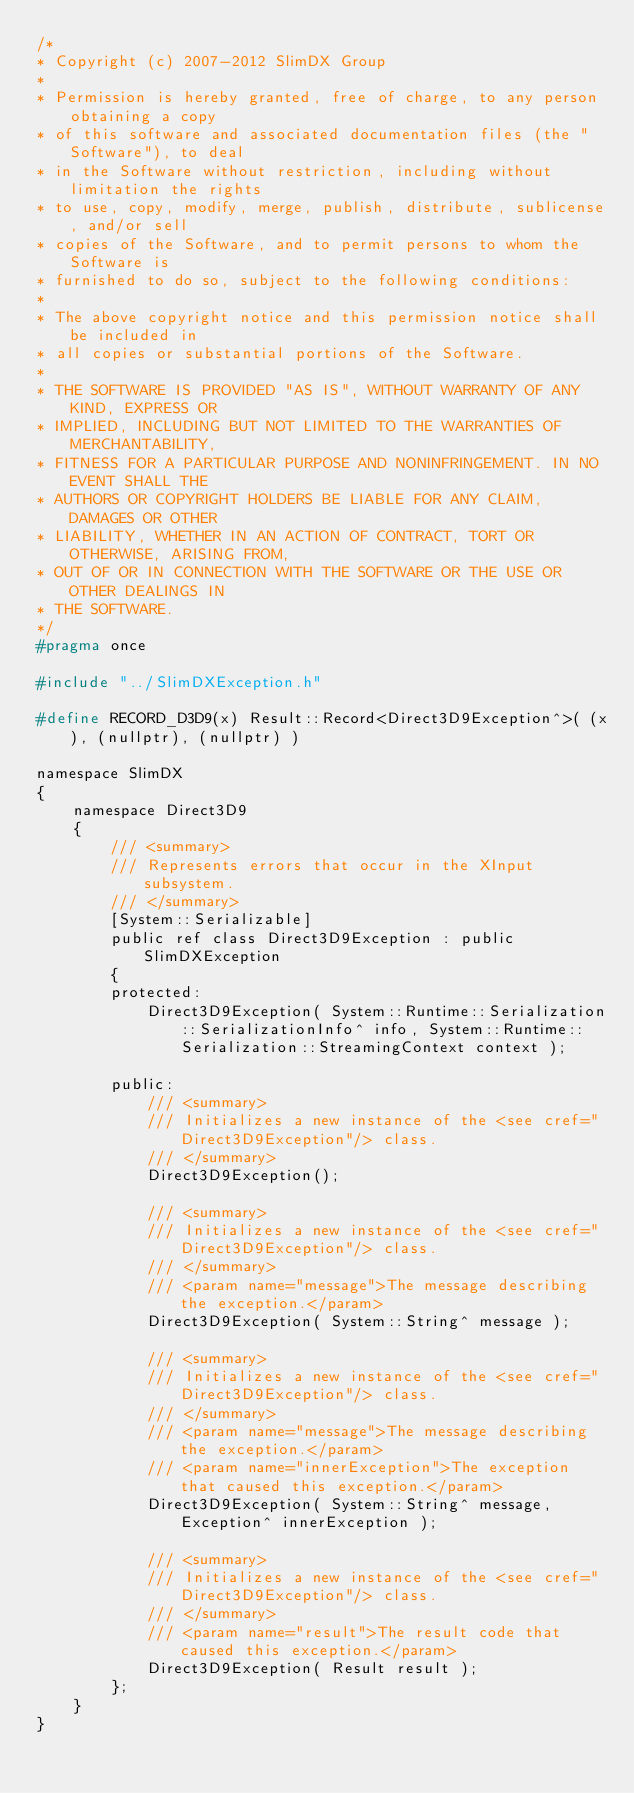Convert code to text. <code><loc_0><loc_0><loc_500><loc_500><_C_>/*
* Copyright (c) 2007-2012 SlimDX Group
* 
* Permission is hereby granted, free of charge, to any person obtaining a copy
* of this software and associated documentation files (the "Software"), to deal
* in the Software without restriction, including without limitation the rights
* to use, copy, modify, merge, publish, distribute, sublicense, and/or sell
* copies of the Software, and to permit persons to whom the Software is
* furnished to do so, subject to the following conditions:
* 
* The above copyright notice and this permission notice shall be included in
* all copies or substantial portions of the Software.
* 
* THE SOFTWARE IS PROVIDED "AS IS", WITHOUT WARRANTY OF ANY KIND, EXPRESS OR
* IMPLIED, INCLUDING BUT NOT LIMITED TO THE WARRANTIES OF MERCHANTABILITY,
* FITNESS FOR A PARTICULAR PURPOSE AND NONINFRINGEMENT. IN NO EVENT SHALL THE
* AUTHORS OR COPYRIGHT HOLDERS BE LIABLE FOR ANY CLAIM, DAMAGES OR OTHER
* LIABILITY, WHETHER IN AN ACTION OF CONTRACT, TORT OR OTHERWISE, ARISING FROM,
* OUT OF OR IN CONNECTION WITH THE SOFTWARE OR THE USE OR OTHER DEALINGS IN
* THE SOFTWARE.
*/
#pragma once

#include "../SlimDXException.h"

#define RECORD_D3D9(x) Result::Record<Direct3D9Exception^>( (x), (nullptr), (nullptr) )

namespace SlimDX
{
	namespace Direct3D9
	{
		/// <summary>
		/// Represents errors that occur in the XInput subsystem.
		/// </summary>
		[System::Serializable]
		public ref class Direct3D9Exception : public SlimDXException
		{
		protected:
			Direct3D9Exception( System::Runtime::Serialization::SerializationInfo^ info, System::Runtime::Serialization::StreamingContext context );
			
		public:
			/// <summary>
			/// Initializes a new instance of the <see cref="Direct3D9Exception"/> class.
			/// </summary>
			Direct3D9Exception();
			
			/// <summary>
			/// Initializes a new instance of the <see cref="Direct3D9Exception"/> class.
			/// </summary>
			/// <param name="message">The message describing the exception.</param>
			Direct3D9Exception( System::String^ message );
			
			/// <summary>
			/// Initializes a new instance of the <see cref="Direct3D9Exception"/> class.
			/// </summary>
			/// <param name="message">The message describing the exception.</param>
			/// <param name="innerException">The exception that caused this exception.</param>
			Direct3D9Exception( System::String^ message, Exception^ innerException );
			
			/// <summary>
			/// Initializes a new instance of the <see cref="Direct3D9Exception"/> class.
			/// </summary>
			/// <param name="result">The result code that caused this exception.</param>
			Direct3D9Exception( Result result );
		};
	}
}</code> 